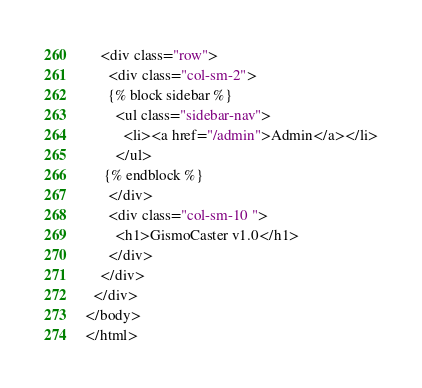<code> <loc_0><loc_0><loc_500><loc_500><_HTML_>    <div class="row">
      <div class="col-sm-2">
      {% block sidebar %}
        <ul class="sidebar-nav">
          <li><a href="/admin">Admin</a></li>
        </ul>
     {% endblock %}
      </div>
      <div class="col-sm-10 ">
        <h1>GismoCaster v1.0</h1>
      </div>
    </div>
  </div>
</body>
</html></code> 